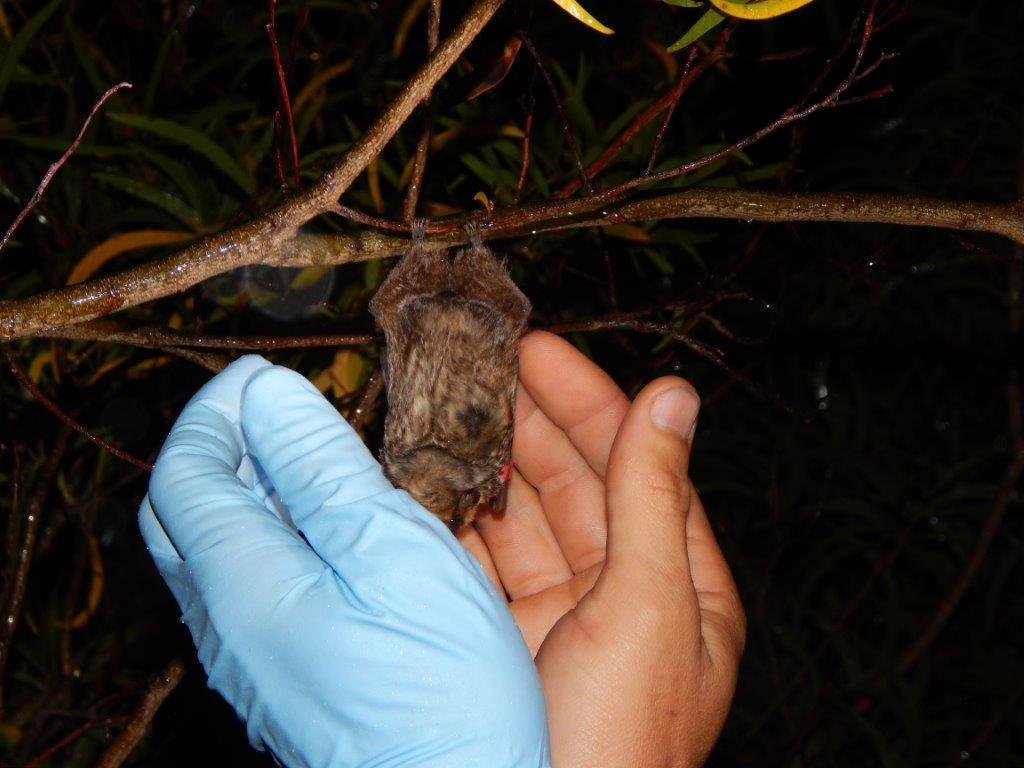What is hanging from the branch in the image? There is a bat hanging from a branch in the image. Who is holding the bat in the image? There is a person holding the bat in the image. What type of vegetation can be seen in the image? There are leaves visible in the image. How would you describe the lighting in the image? The backdrop of the image is dark. What number is written on the bat in the image? There is no number written on the bat in the image. What event is taking place in the image? The image does not depict a specific event; it simply shows a bat hanging from a branch and a person holding it. 